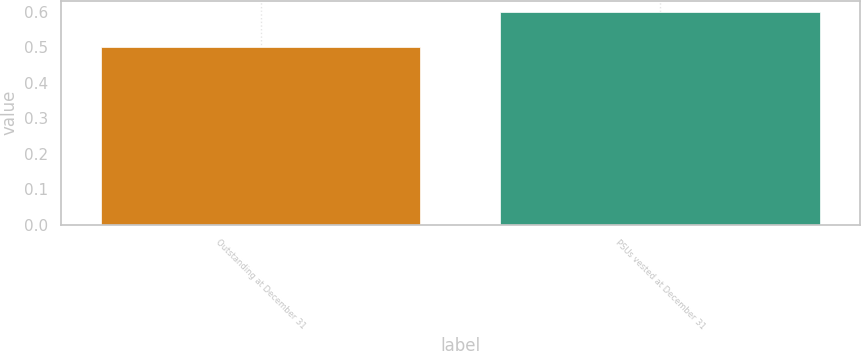Convert chart. <chart><loc_0><loc_0><loc_500><loc_500><bar_chart><fcel>Outstanding at December 31<fcel>PSUs vested at December 31<nl><fcel>0.5<fcel>0.6<nl></chart> 